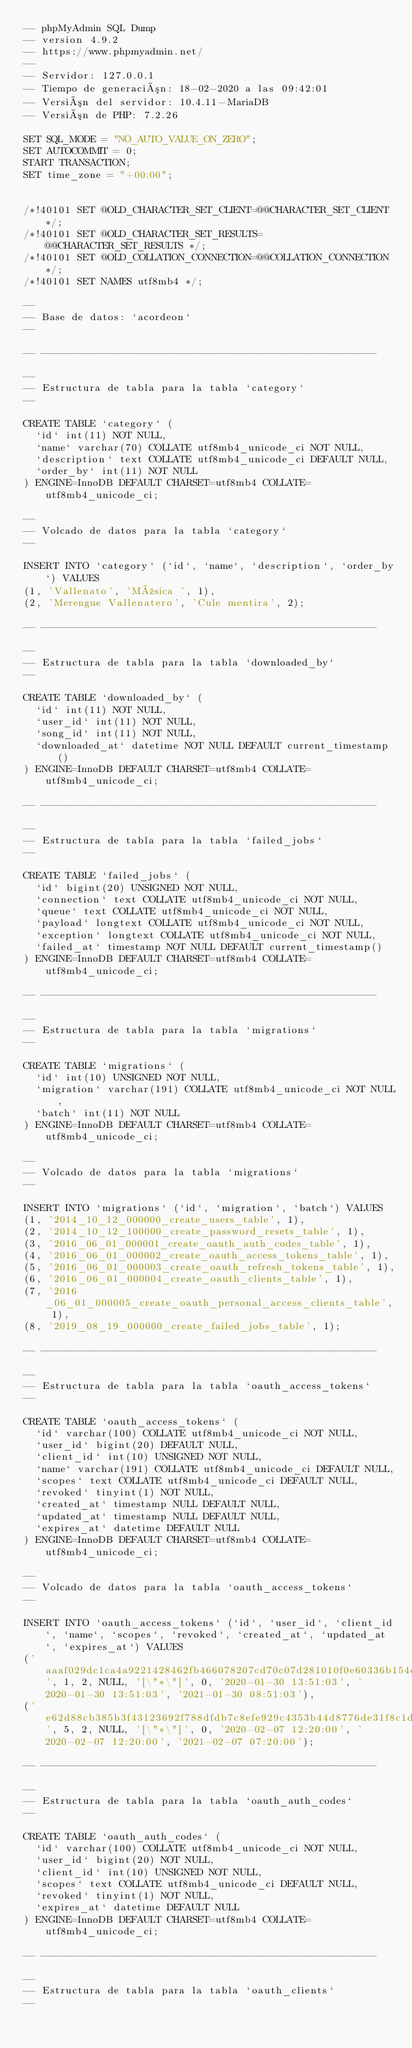Convert code to text. <code><loc_0><loc_0><loc_500><loc_500><_SQL_>-- phpMyAdmin SQL Dump
-- version 4.9.2
-- https://www.phpmyadmin.net/
--
-- Servidor: 127.0.0.1
-- Tiempo de generación: 18-02-2020 a las 09:42:01
-- Versión del servidor: 10.4.11-MariaDB
-- Versión de PHP: 7.2.26

SET SQL_MODE = "NO_AUTO_VALUE_ON_ZERO";
SET AUTOCOMMIT = 0;
START TRANSACTION;
SET time_zone = "+00:00";


/*!40101 SET @OLD_CHARACTER_SET_CLIENT=@@CHARACTER_SET_CLIENT */;
/*!40101 SET @OLD_CHARACTER_SET_RESULTS=@@CHARACTER_SET_RESULTS */;
/*!40101 SET @OLD_COLLATION_CONNECTION=@@COLLATION_CONNECTION */;
/*!40101 SET NAMES utf8mb4 */;

--
-- Base de datos: `acordeon`
--

-- --------------------------------------------------------

--
-- Estructura de tabla para la tabla `category`
--

CREATE TABLE `category` (
  `id` int(11) NOT NULL,
  `name` varchar(70) COLLATE utf8mb4_unicode_ci NOT NULL,
  `description` text COLLATE utf8mb4_unicode_ci DEFAULT NULL,
  `order_by` int(11) NOT NULL
) ENGINE=InnoDB DEFAULT CHARSET=utf8mb4 COLLATE=utf8mb4_unicode_ci;

--
-- Volcado de datos para la tabla `category`
--

INSERT INTO `category` (`id`, `name`, `description`, `order_by`) VALUES
(1, 'Vallenato', 'Música ', 1),
(2, 'Merengue Vallenatero', 'Cule mentira', 2);

-- --------------------------------------------------------

--
-- Estructura de tabla para la tabla `downloaded_by`
--

CREATE TABLE `downloaded_by` (
  `id` int(11) NOT NULL,
  `user_id` int(11) NOT NULL,
  `song_id` int(11) NOT NULL,
  `downloaded_at` datetime NOT NULL DEFAULT current_timestamp()
) ENGINE=InnoDB DEFAULT CHARSET=utf8mb4 COLLATE=utf8mb4_unicode_ci;

-- --------------------------------------------------------

--
-- Estructura de tabla para la tabla `failed_jobs`
--

CREATE TABLE `failed_jobs` (
  `id` bigint(20) UNSIGNED NOT NULL,
  `connection` text COLLATE utf8mb4_unicode_ci NOT NULL,
  `queue` text COLLATE utf8mb4_unicode_ci NOT NULL,
  `payload` longtext COLLATE utf8mb4_unicode_ci NOT NULL,
  `exception` longtext COLLATE utf8mb4_unicode_ci NOT NULL,
  `failed_at` timestamp NOT NULL DEFAULT current_timestamp()
) ENGINE=InnoDB DEFAULT CHARSET=utf8mb4 COLLATE=utf8mb4_unicode_ci;

-- --------------------------------------------------------

--
-- Estructura de tabla para la tabla `migrations`
--

CREATE TABLE `migrations` (
  `id` int(10) UNSIGNED NOT NULL,
  `migration` varchar(191) COLLATE utf8mb4_unicode_ci NOT NULL,
  `batch` int(11) NOT NULL
) ENGINE=InnoDB DEFAULT CHARSET=utf8mb4 COLLATE=utf8mb4_unicode_ci;

--
-- Volcado de datos para la tabla `migrations`
--

INSERT INTO `migrations` (`id`, `migration`, `batch`) VALUES
(1, '2014_10_12_000000_create_users_table', 1),
(2, '2014_10_12_100000_create_password_resets_table', 1),
(3, '2016_06_01_000001_create_oauth_auth_codes_table', 1),
(4, '2016_06_01_000002_create_oauth_access_tokens_table', 1),
(5, '2016_06_01_000003_create_oauth_refresh_tokens_table', 1),
(6, '2016_06_01_000004_create_oauth_clients_table', 1),
(7, '2016_06_01_000005_create_oauth_personal_access_clients_table', 1),
(8, '2019_08_19_000000_create_failed_jobs_table', 1);

-- --------------------------------------------------------

--
-- Estructura de tabla para la tabla `oauth_access_tokens`
--

CREATE TABLE `oauth_access_tokens` (
  `id` varchar(100) COLLATE utf8mb4_unicode_ci NOT NULL,
  `user_id` bigint(20) DEFAULT NULL,
  `client_id` int(10) UNSIGNED NOT NULL,
  `name` varchar(191) COLLATE utf8mb4_unicode_ci DEFAULT NULL,
  `scopes` text COLLATE utf8mb4_unicode_ci DEFAULT NULL,
  `revoked` tinyint(1) NOT NULL,
  `created_at` timestamp NULL DEFAULT NULL,
  `updated_at` timestamp NULL DEFAULT NULL,
  `expires_at` datetime DEFAULT NULL
) ENGINE=InnoDB DEFAULT CHARSET=utf8mb4 COLLATE=utf8mb4_unicode_ci;

--
-- Volcado de datos para la tabla `oauth_access_tokens`
--

INSERT INTO `oauth_access_tokens` (`id`, `user_id`, `client_id`, `name`, `scopes`, `revoked`, `created_at`, `updated_at`, `expires_at`) VALUES
('aaaf029dc1ca4a9221428462fb466078207cd70c07d281010f0e60336b154de056963c21e29a4e01', 1, 2, NULL, '[\"*\"]', 0, '2020-01-30 13:51:03', '2020-01-30 13:51:03', '2021-01-30 08:51:03'),
('e62d88cb385b3f43123692f788dfdb7c8efe929c4353b44d8776de31f8c1d6bfeeaefcf73195cbcd', 5, 2, NULL, '[\"*\"]', 0, '2020-02-07 12:20:00', '2020-02-07 12:20:00', '2021-02-07 07:20:00');

-- --------------------------------------------------------

--
-- Estructura de tabla para la tabla `oauth_auth_codes`
--

CREATE TABLE `oauth_auth_codes` (
  `id` varchar(100) COLLATE utf8mb4_unicode_ci NOT NULL,
  `user_id` bigint(20) NOT NULL,
  `client_id` int(10) UNSIGNED NOT NULL,
  `scopes` text COLLATE utf8mb4_unicode_ci DEFAULT NULL,
  `revoked` tinyint(1) NOT NULL,
  `expires_at` datetime DEFAULT NULL
) ENGINE=InnoDB DEFAULT CHARSET=utf8mb4 COLLATE=utf8mb4_unicode_ci;

-- --------------------------------------------------------

--
-- Estructura de tabla para la tabla `oauth_clients`
--
</code> 